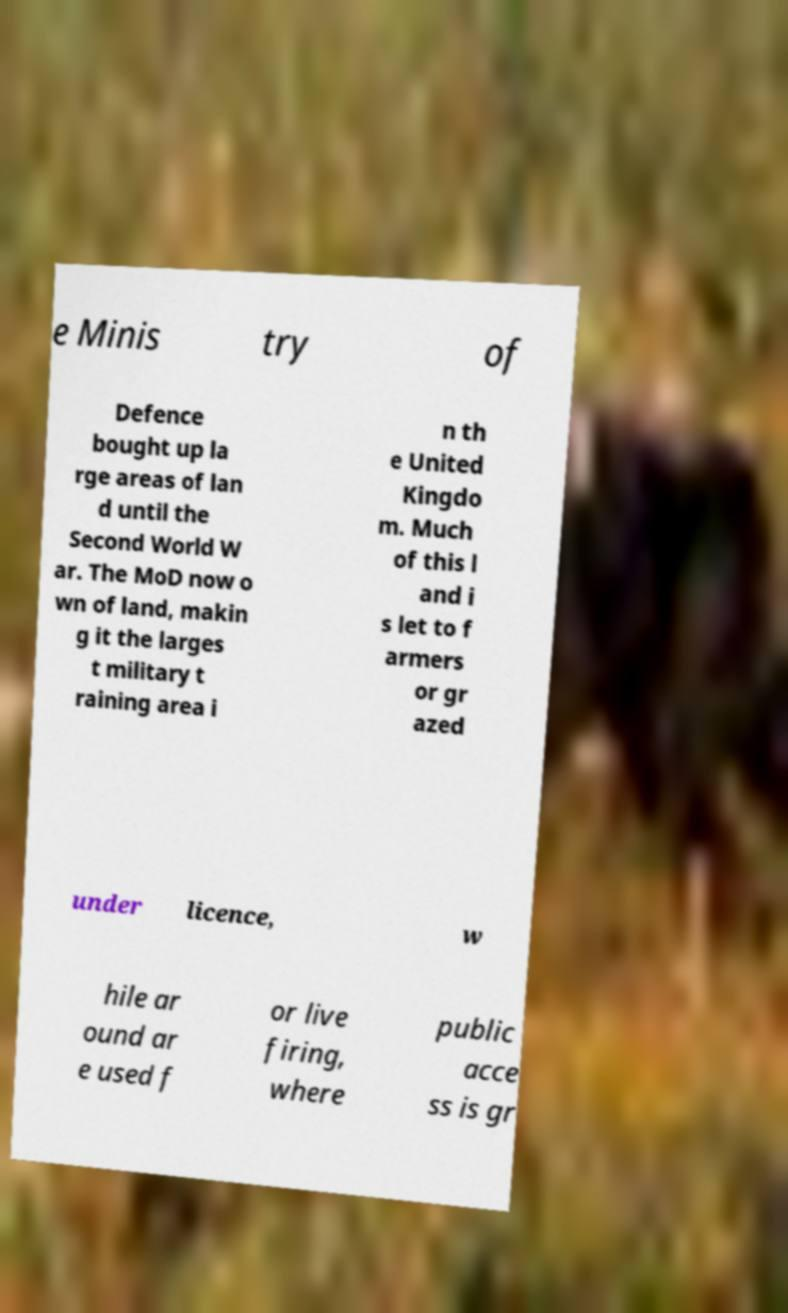Can you accurately transcribe the text from the provided image for me? e Minis try of Defence bought up la rge areas of lan d until the Second World W ar. The MoD now o wn of land, makin g it the larges t military t raining area i n th e United Kingdo m. Much of this l and i s let to f armers or gr azed under licence, w hile ar ound ar e used f or live firing, where public acce ss is gr 